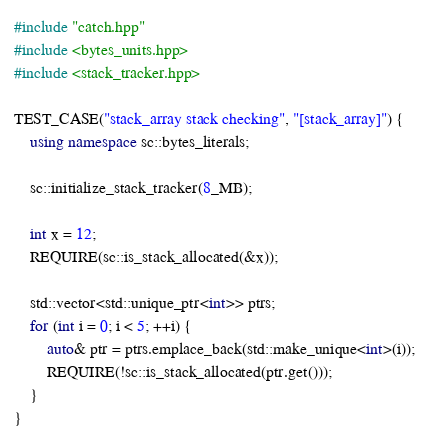Convert code to text. <code><loc_0><loc_0><loc_500><loc_500><_C++_>
#include "catch.hpp"
#include <bytes_units.hpp>
#include <stack_tracker.hpp>

TEST_CASE("stack_array stack checking", "[stack_array]") {
    using namespace sc::bytes_literals;

    sc::initialize_stack_tracker(8_MB);

    int x = 12;
    REQUIRE(sc::is_stack_allocated(&x));

    std::vector<std::unique_ptr<int>> ptrs;
    for (int i = 0; i < 5; ++i) {
        auto& ptr = ptrs.emplace_back(std::make_unique<int>(i));
        REQUIRE(!sc::is_stack_allocated(ptr.get()));
    }
}
</code> 